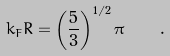<formula> <loc_0><loc_0><loc_500><loc_500>k _ { F } R = \left ( \frac { 5 } { 3 } \right ) ^ { 1 / 2 } \pi \quad .</formula> 